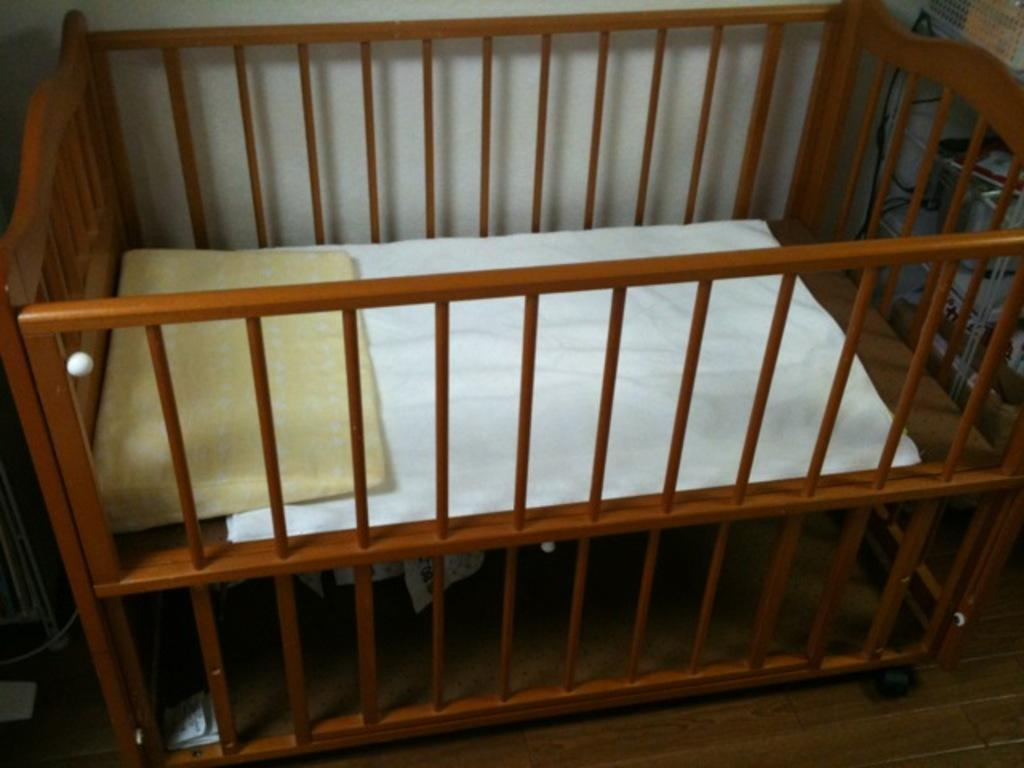What is in the infant bed in the image? There is a pillow and a cloth in the infant bed. Where is the infant bed located? The infant bed is on the floor. What can be seen in the background of the image? There is a wall in the background of the image. What is visible on the right side of the image? There are objects visible on the right side of the image. What type of bone can be seen in the image? There is no bone present in the image. What is the source of power in the image? There is no mention of power or any related objects in the image. 